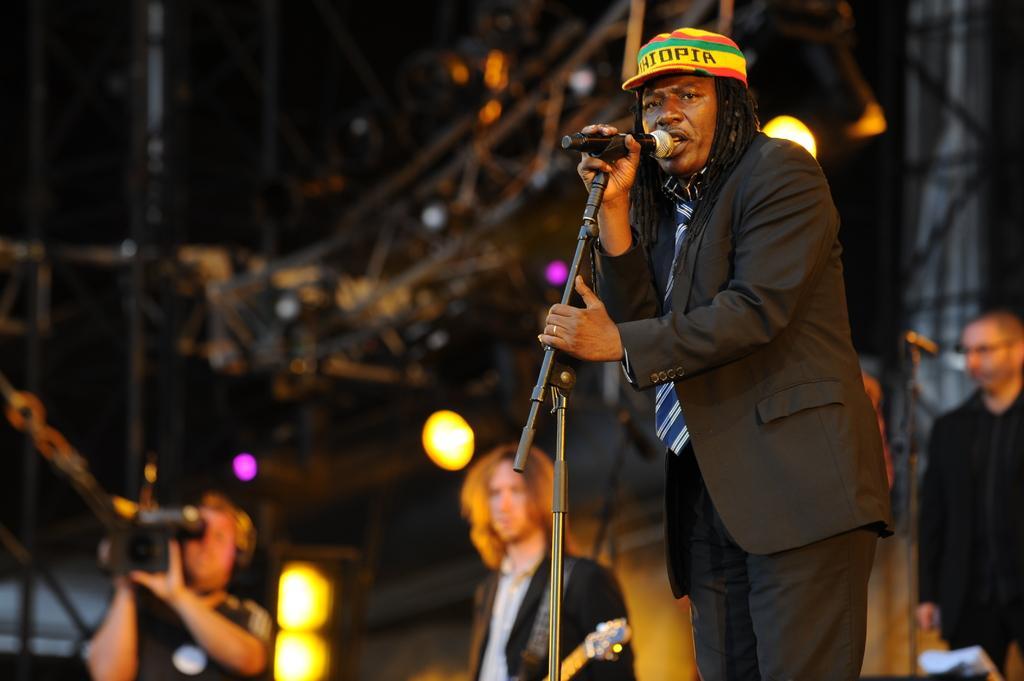How would you summarize this image in a sentence or two? In the image we can see there is a person who is standing and he is holding mic in his hand and he is wearing formal suit and beside him there at the back there are lot of people who are standing and they are holding guitar and camera video recorder in their hand. 